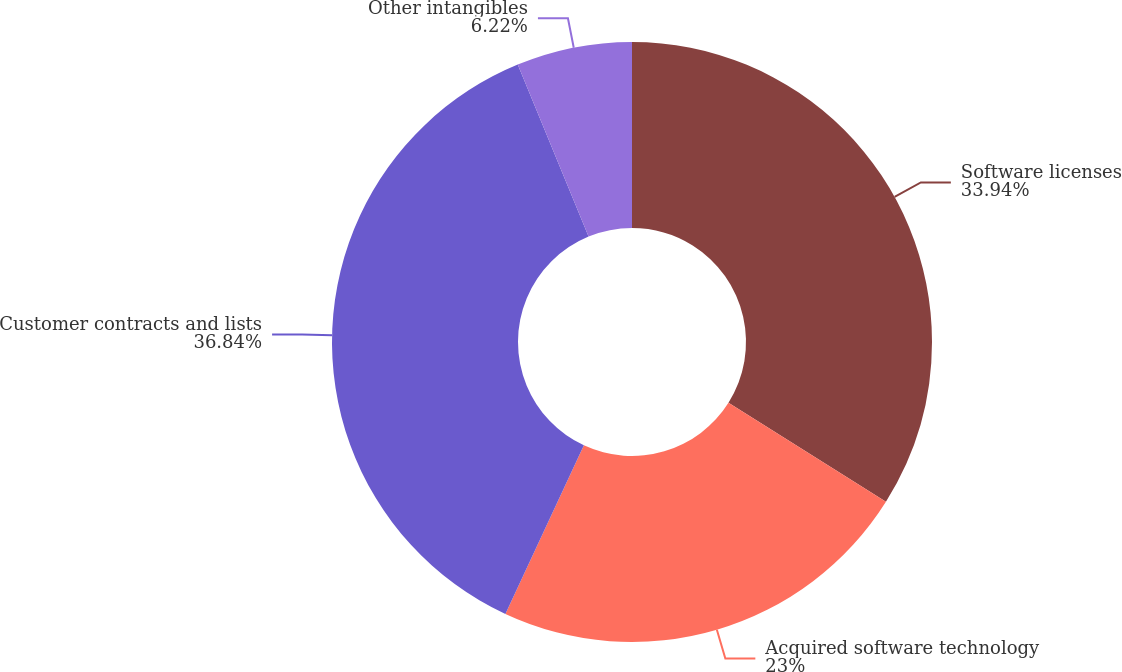Convert chart. <chart><loc_0><loc_0><loc_500><loc_500><pie_chart><fcel>Software licenses<fcel>Acquired software technology<fcel>Customer contracts and lists<fcel>Other intangibles<nl><fcel>33.94%<fcel>23.0%<fcel>36.85%<fcel>6.22%<nl></chart> 